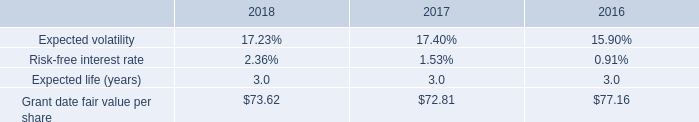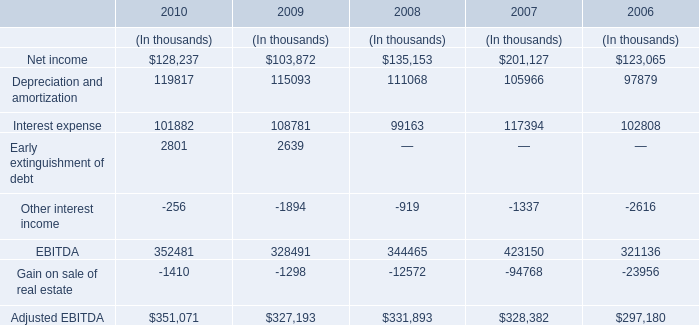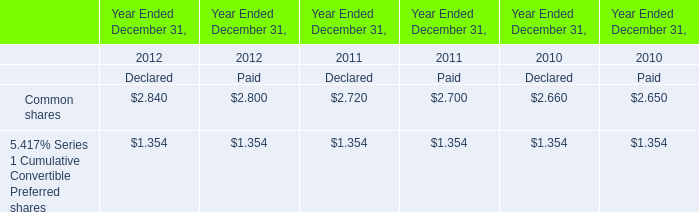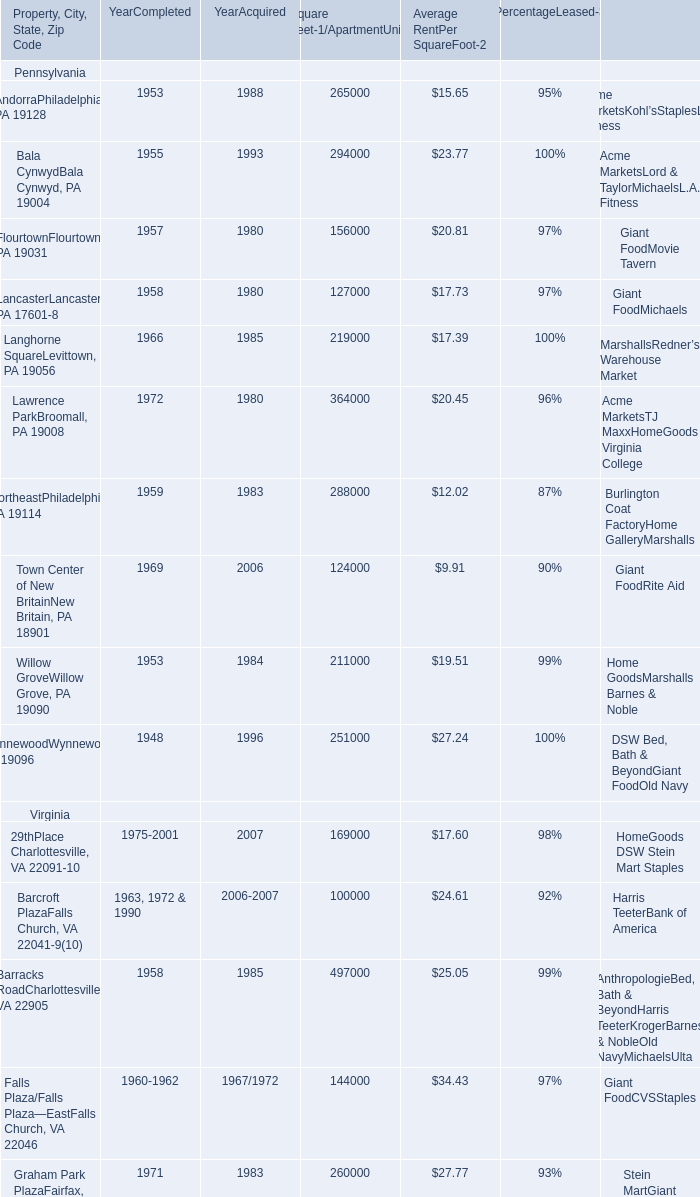what was the purchase price of common stock acquired under the espp in 2018? 
Computations: (90% * 73.62)
Answer: 66.258. 